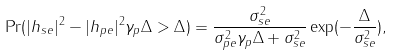Convert formula to latex. <formula><loc_0><loc_0><loc_500><loc_500>\Pr ( { | h _ { s e } | ^ { 2 } - | h _ { p e } | ^ { 2 } \gamma _ { p } \Delta > \Delta } ) = \frac { { \sigma _ { s e } ^ { 2 } } } { { \sigma _ { p e } ^ { 2 } \gamma _ { p } \Delta + \sigma _ { s e } ^ { 2 } } } \exp ( - \frac { \Delta } { { \sigma _ { s e } ^ { 2 } } } ) ,</formula> 